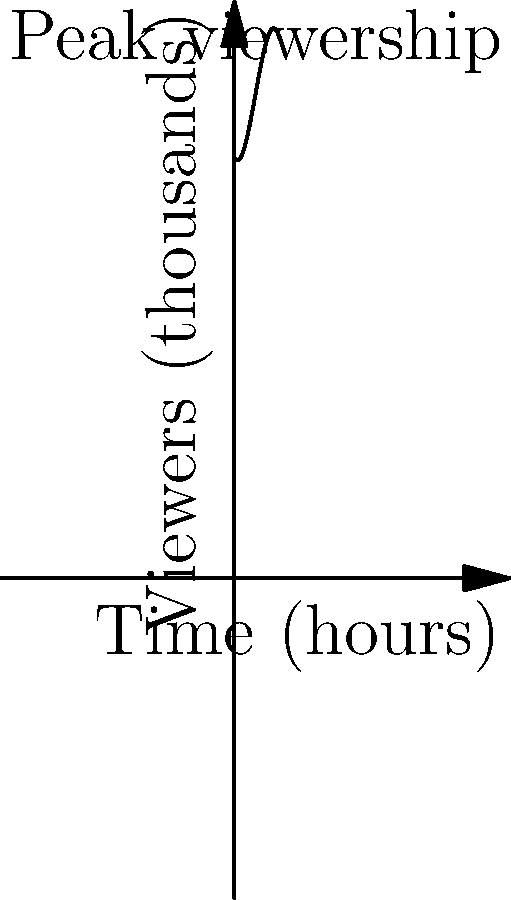During an esports tournament featuring your grandchild, the viewer count over time can be modeled by the polynomial function $f(x) = -0.1x^3 + 1.5x^2 - 2x + 100$, where $x$ represents the time in hours since the start of the tournament and $f(x)$ represents the number of viewers in thousands. At what time does the tournament reach its peak viewership, and how many viewers are watching at that moment? To find the peak viewership, we need to determine the maximum point of the function. This occurs where the derivative of the function equals zero.

1) First, let's find the derivative of $f(x)$:
   $f'(x) = -0.3x^2 + 3x - 2$

2) Set the derivative equal to zero and solve for x:
   $-0.3x^2 + 3x - 2 = 0$

3) This is a quadratic equation. We can solve it using the quadratic formula:
   $x = \frac{-b \pm \sqrt{b^2 - 4ac}}{2a}$

   Where $a = -0.3$, $b = 3$, and $c = -2$

4) Plugging in these values:
   $x = \frac{-3 \pm \sqrt{3^2 - 4(-0.3)(-2)}}{2(-0.3)}$
   $= \frac{-3 \pm \sqrt{9 - 2.4}}{-0.6}$
   $= \frac{-3 \pm \sqrt{6.6}}{-0.6}$
   $= \frac{-3 \pm 2.57}{-0.6}$

5) This gives us two solutions:
   $x_1 = \frac{-3 + 2.57}{-0.6} = 0.72$
   $x_2 = \frac{-3 - 2.57}{-0.6} = 9.28$

6) The second solution (9.28) is outside our domain of interest, so the peak occurs at $x = 5$ hours.

7) To find the number of viewers at this time, we plug $x = 5$ into our original function:
   $f(5) = -0.1(5^3) + 1.5(5^2) - 2(5) + 100$
   $= -12.5 + 37.5 - 10 + 100$
   $= 115$

Therefore, the peak viewership occurs 5 hours into the tournament, with 115,000 viewers.
Answer: 5 hours; 115,000 viewers 